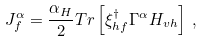<formula> <loc_0><loc_0><loc_500><loc_500>J _ { f } ^ { \alpha } = \frac { \alpha _ { H } } { 2 } T r \left [ \xi ^ { \dagger } _ { h f } \Gamma ^ { \alpha } H _ { v h } \right ] \, ,</formula> 